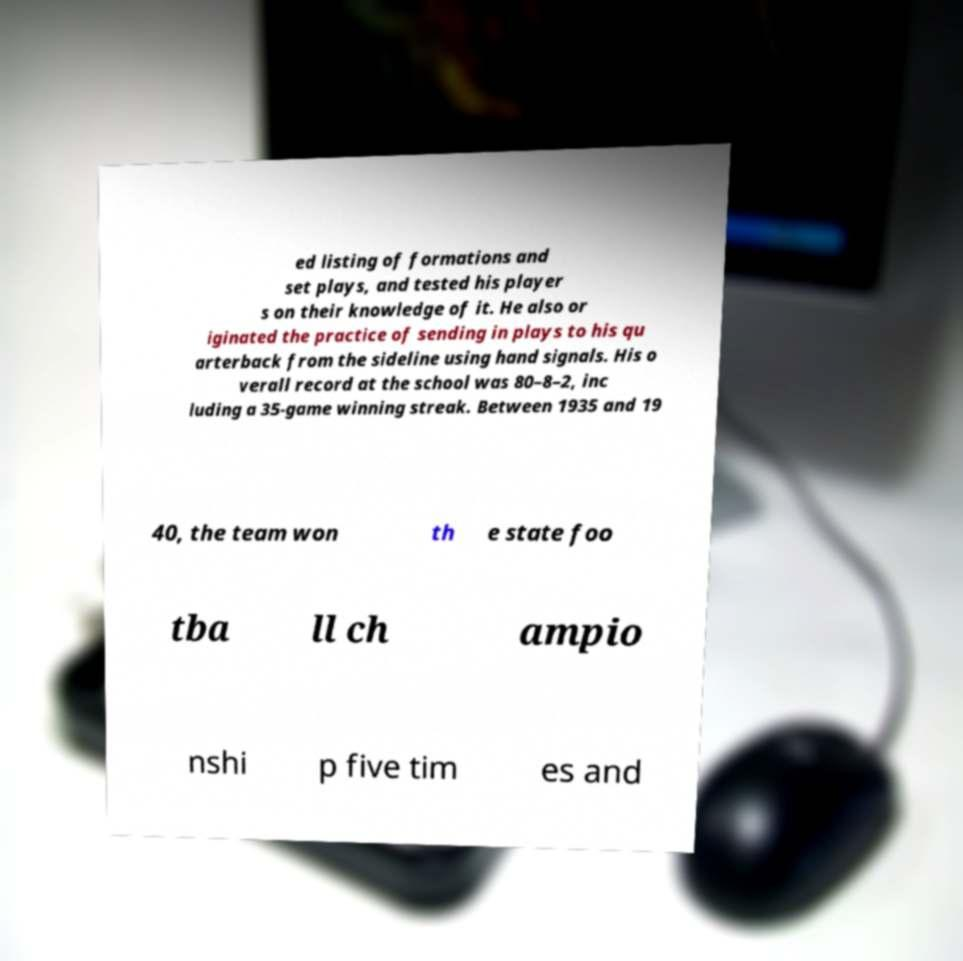Could you extract and type out the text from this image? ed listing of formations and set plays, and tested his player s on their knowledge of it. He also or iginated the practice of sending in plays to his qu arterback from the sideline using hand signals. His o verall record at the school was 80–8–2, inc luding a 35-game winning streak. Between 1935 and 19 40, the team won th e state foo tba ll ch ampio nshi p five tim es and 